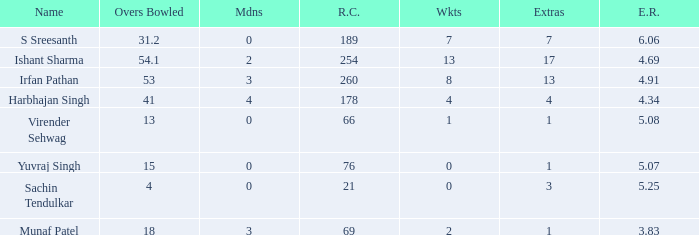Name the wickets for overs bowled being 15 0.0. 